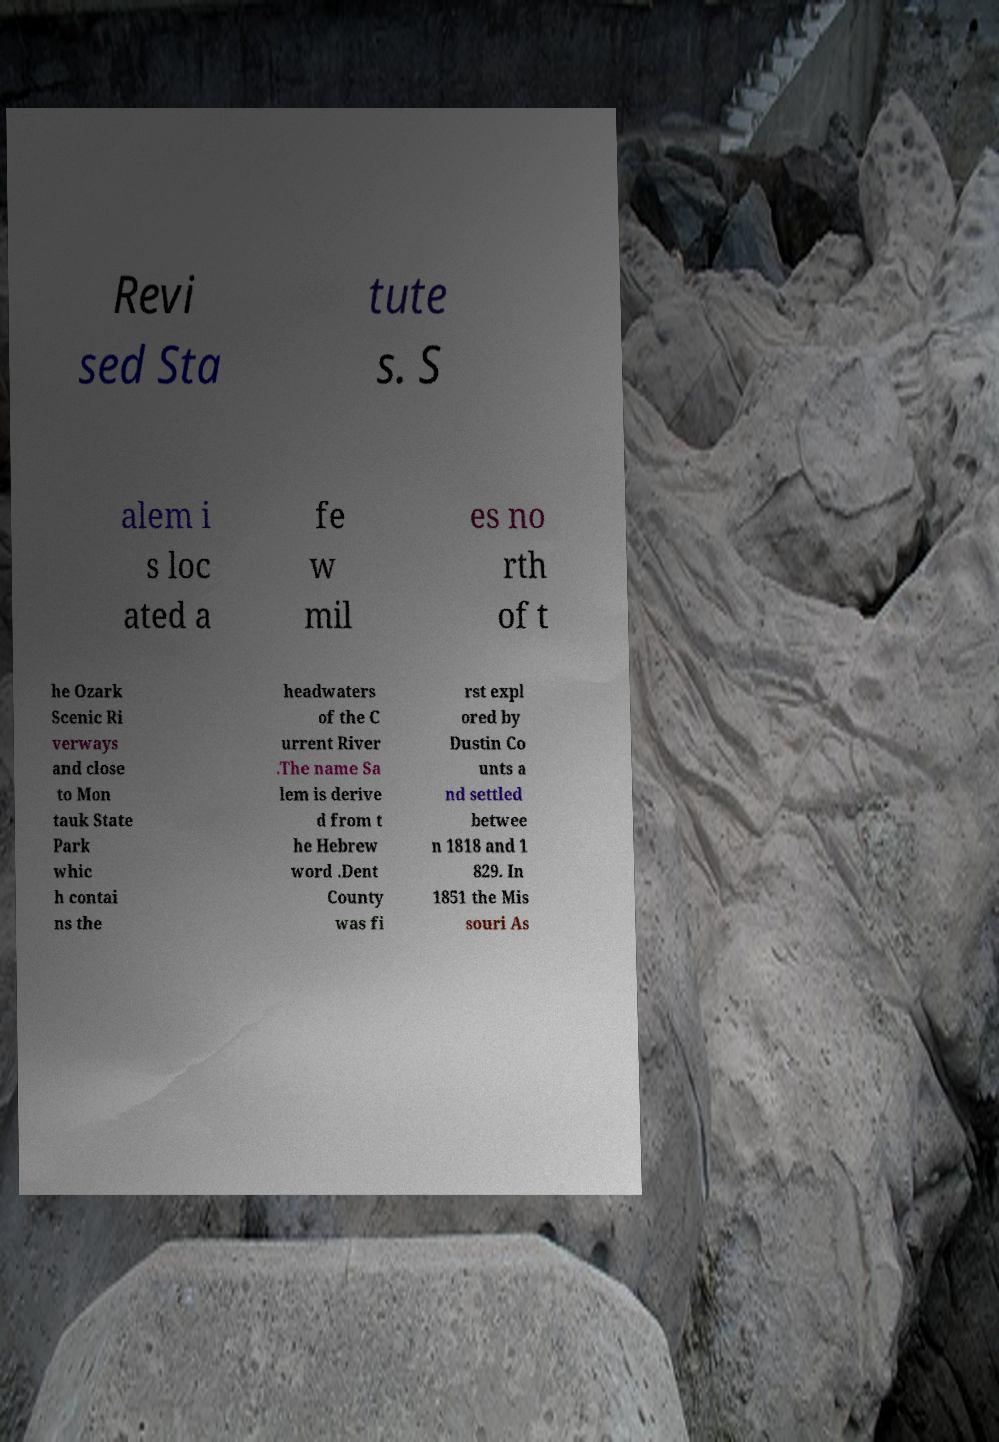Please read and relay the text visible in this image. What does it say? Revi sed Sta tute s. S alem i s loc ated a fe w mil es no rth of t he Ozark Scenic Ri verways and close to Mon tauk State Park whic h contai ns the headwaters of the C urrent River .The name Sa lem is derive d from t he Hebrew word .Dent County was fi rst expl ored by Dustin Co unts a nd settled betwee n 1818 and 1 829. In 1851 the Mis souri As 